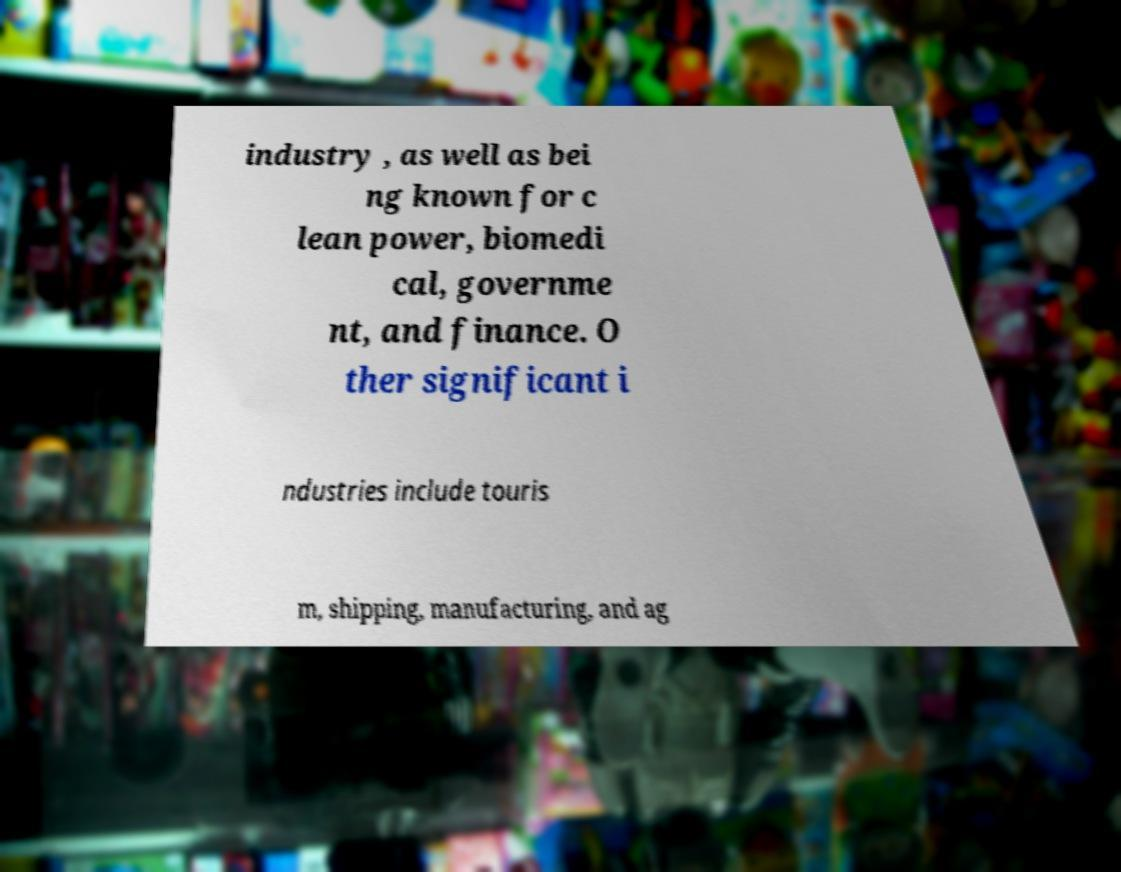Can you read and provide the text displayed in the image?This photo seems to have some interesting text. Can you extract and type it out for me? industry , as well as bei ng known for c lean power, biomedi cal, governme nt, and finance. O ther significant i ndustries include touris m, shipping, manufacturing, and ag 